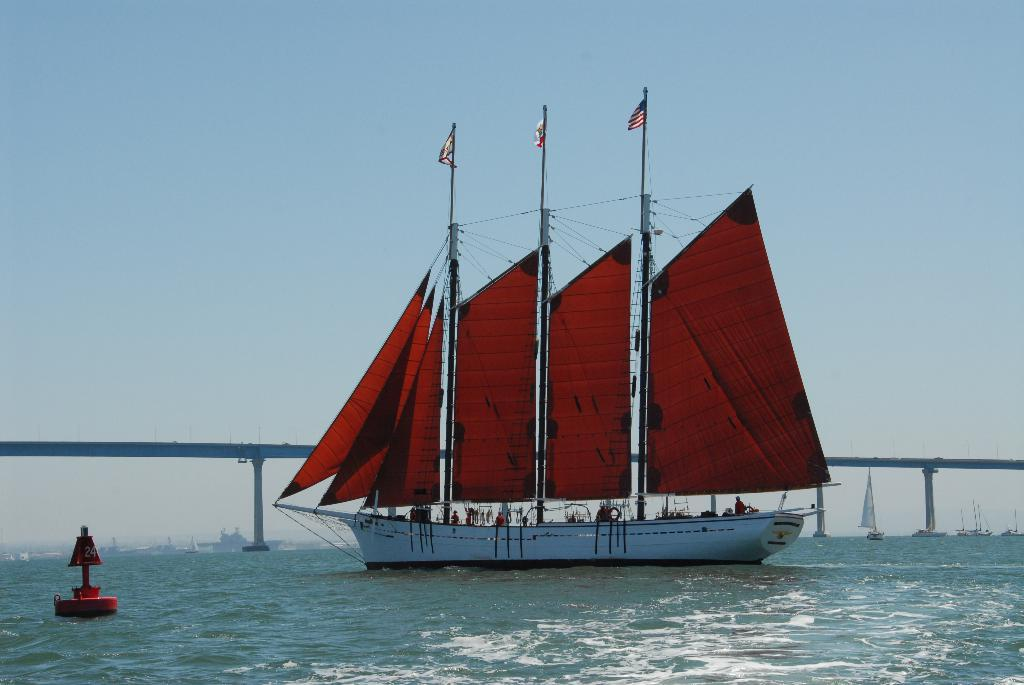What type of vehicles can be seen in the water in the image? There are boats in the water in the image. What color is the object floating on the water? The object on the water is red. What structure can be seen in the background of the image? There is a bridge visible in the background. What part of the natural environment is visible in the image? The sky is visible in the background. What type of blade is being used by the mom in the boat? There is no mom or blade present in the image. How many boats are visible in the image? The image shows multiple boats in the water, but the exact number cannot be determined from the provided facts. 